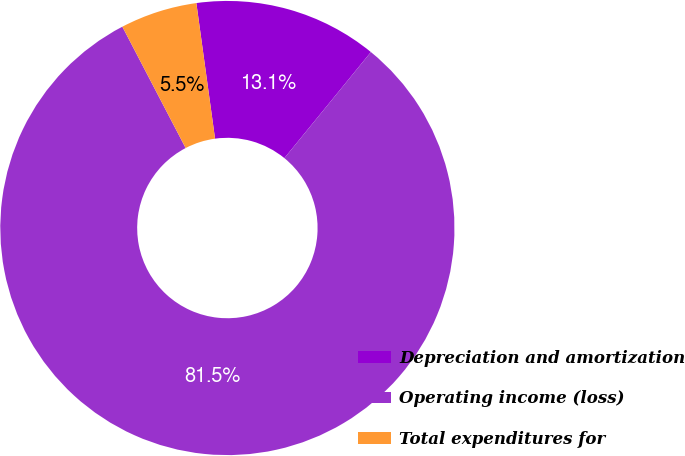<chart> <loc_0><loc_0><loc_500><loc_500><pie_chart><fcel>Depreciation and amortization<fcel>Operating income (loss)<fcel>Total expenditures for<nl><fcel>13.07%<fcel>81.45%<fcel>5.47%<nl></chart> 